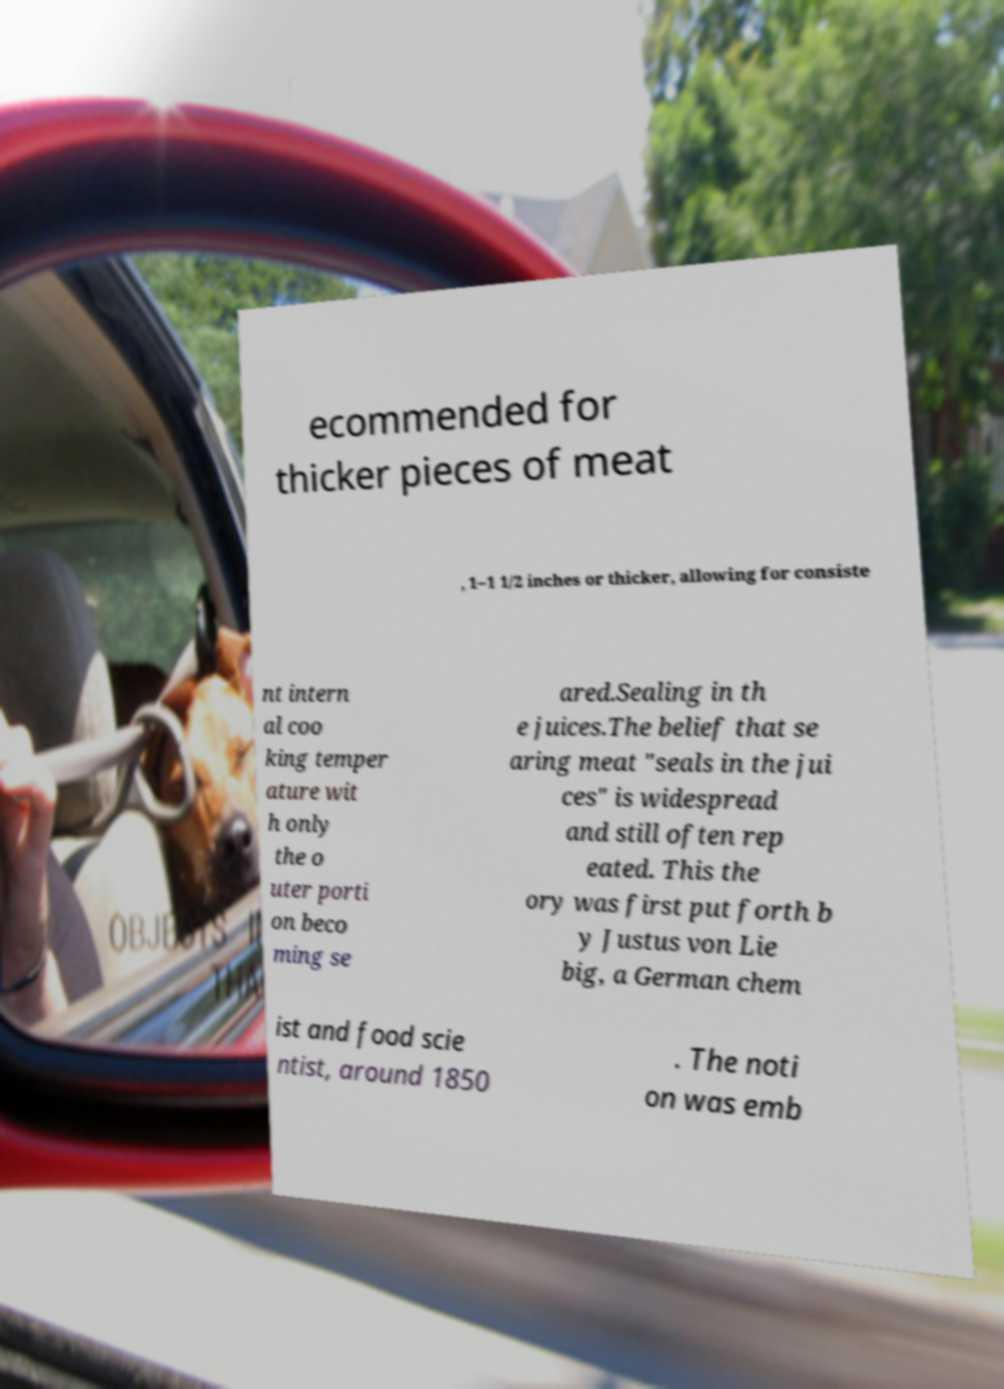What messages or text are displayed in this image? I need them in a readable, typed format. ecommended for thicker pieces of meat , 1–1 1/2 inches or thicker, allowing for consiste nt intern al coo king temper ature wit h only the o uter porti on beco ming se ared.Sealing in th e juices.The belief that se aring meat "seals in the jui ces" is widespread and still often rep eated. This the ory was first put forth b y Justus von Lie big, a German chem ist and food scie ntist, around 1850 . The noti on was emb 